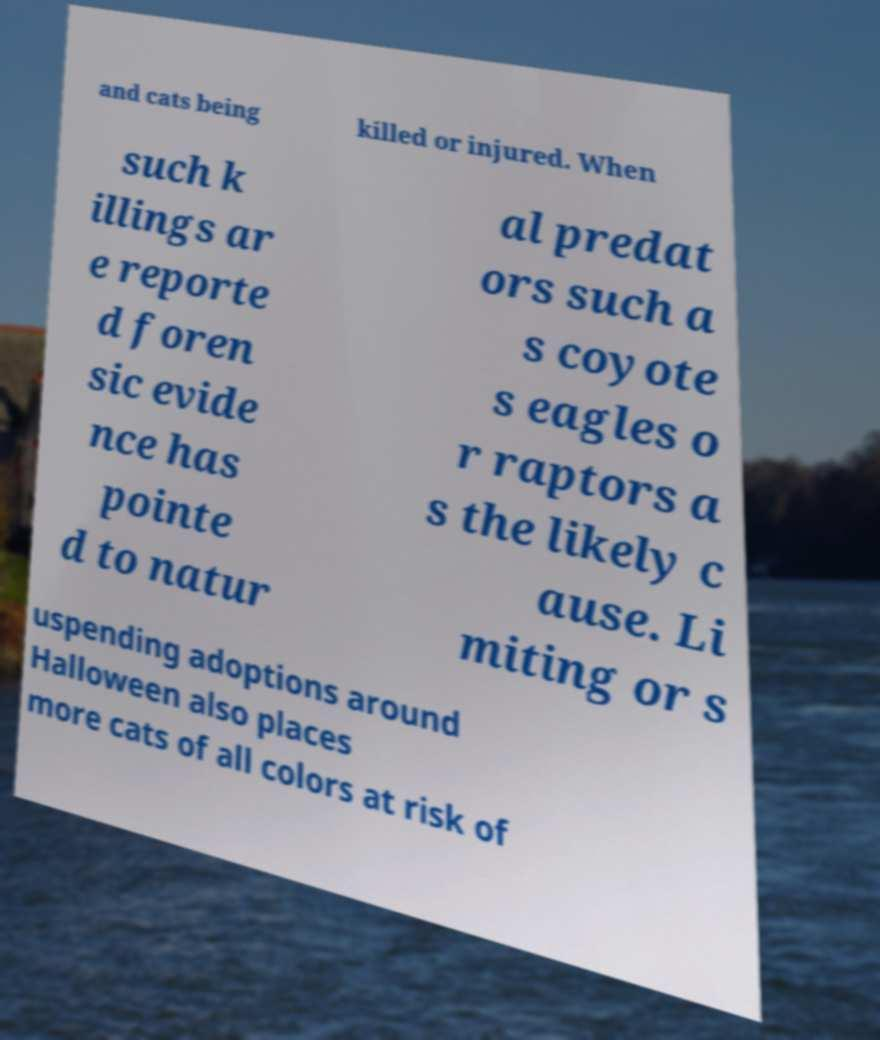What messages or text are displayed in this image? I need them in a readable, typed format. and cats being killed or injured. When such k illings ar e reporte d foren sic evide nce has pointe d to natur al predat ors such a s coyote s eagles o r raptors a s the likely c ause. Li miting or s uspending adoptions around Halloween also places more cats of all colors at risk of 